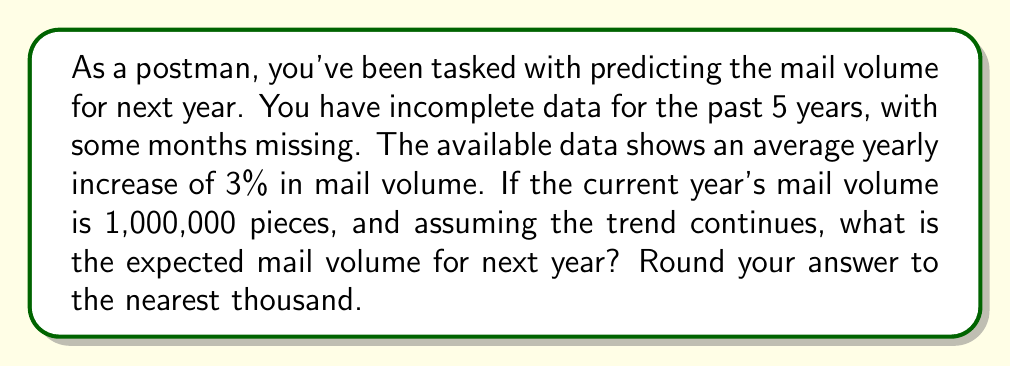Teach me how to tackle this problem. Let's approach this step-by-step:

1) We're given that the current year's mail volume is 1,000,000 pieces.

2) The data shows an average yearly increase of 3%.

3) To calculate the expected mail volume for next year, we need to increase the current volume by 3%.

4) Mathematically, this can be expressed as:

   $$\text{Next Year's Volume} = \text{Current Volume} \times (1 + \text{Growth Rate})$$

5) Plugging in the values:

   $$\text{Next Year's Volume} = 1,000,000 \times (1 + 0.03)$$

6) Simplify:

   $$\text{Next Year's Volume} = 1,000,000 \times 1.03 = 1,030,000$$

7) The question asks to round to the nearest thousand, but 1,030,000 is already at the thousand level, so no further rounding is necessary.

This prediction method is an example of a simple linear growth model, which is a basic approach to solving inverse problems with incomplete data. More sophisticated models might consider seasonal variations, economic factors, or changes in communication habits.
Answer: 1,030,000 pieces 